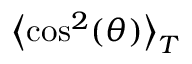<formula> <loc_0><loc_0><loc_500><loc_500>\left \langle \cos ^ { 2 } ( \theta ) \right \rangle _ { T }</formula> 